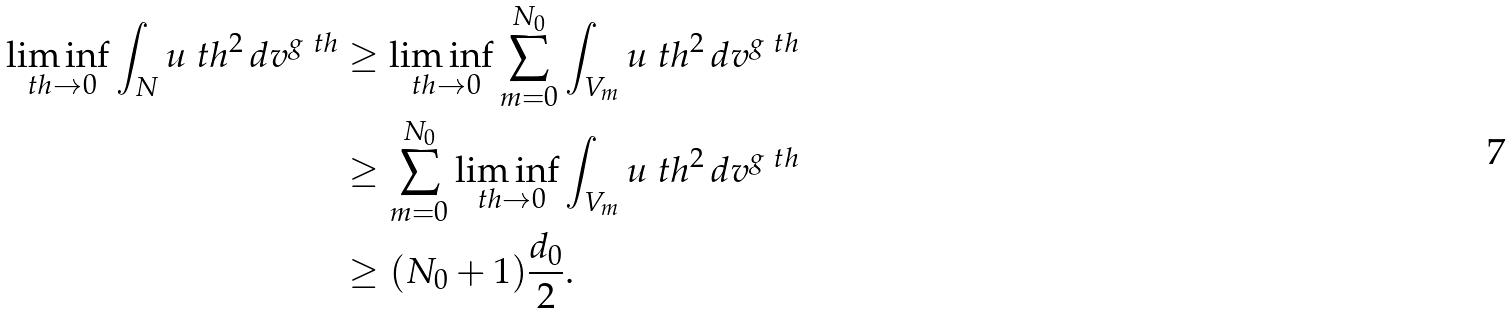Convert formula to latex. <formula><loc_0><loc_0><loc_500><loc_500>\liminf _ { \ t h \to 0 } \int _ { N } u _ { \ } t h ^ { 2 } \, d v ^ { g _ { \ } t h } & \geq \liminf _ { \ t h \to 0 } \sum _ { m = 0 } ^ { N _ { 0 } } \int _ { V _ { m } } u _ { \ } t h ^ { 2 } \, d v ^ { g _ { \ } t h } \\ & \geq \sum _ { m = 0 } ^ { N _ { 0 } } \liminf _ { \ t h \to 0 } \int _ { V _ { m } } u _ { \ } t h ^ { 2 } \, d v ^ { g _ { \ } t h } \\ & \geq ( N _ { 0 } + 1 ) \frac { d _ { 0 } } { 2 } .</formula> 